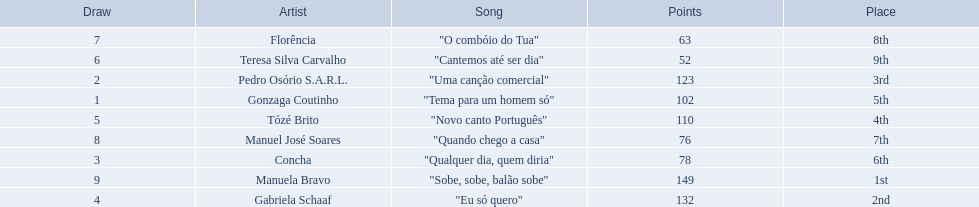Is there a song called eu so quero in the table? "Eu só quero". Who sang that song? Gabriela Schaaf. 